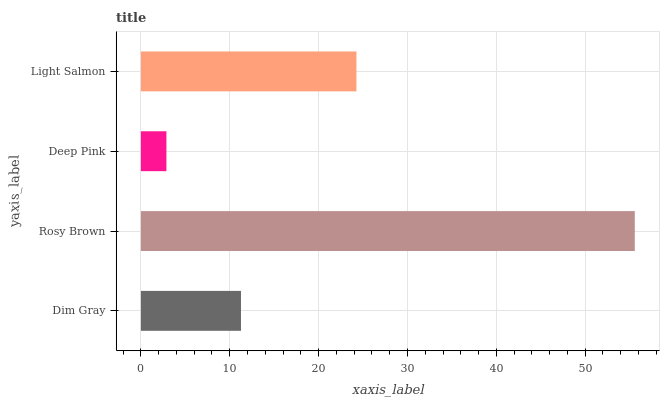Is Deep Pink the minimum?
Answer yes or no. Yes. Is Rosy Brown the maximum?
Answer yes or no. Yes. Is Rosy Brown the minimum?
Answer yes or no. No. Is Deep Pink the maximum?
Answer yes or no. No. Is Rosy Brown greater than Deep Pink?
Answer yes or no. Yes. Is Deep Pink less than Rosy Brown?
Answer yes or no. Yes. Is Deep Pink greater than Rosy Brown?
Answer yes or no. No. Is Rosy Brown less than Deep Pink?
Answer yes or no. No. Is Light Salmon the high median?
Answer yes or no. Yes. Is Dim Gray the low median?
Answer yes or no. Yes. Is Dim Gray the high median?
Answer yes or no. No. Is Rosy Brown the low median?
Answer yes or no. No. 